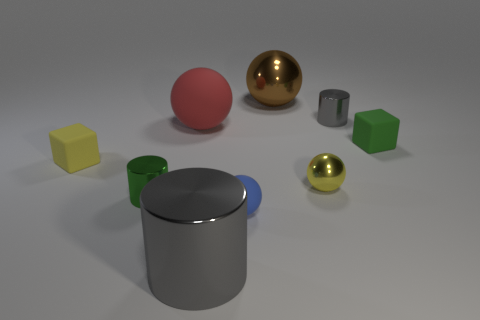Is the size of the gray metal thing on the left side of the big brown shiny ball the same as the shiny cylinder on the right side of the large gray shiny thing?
Your response must be concise. No. There is a large rubber thing that is the same shape as the yellow metal object; what is its color?
Offer a terse response. Red. Does the small green rubber object have the same shape as the red rubber thing?
Keep it short and to the point. No. What is the size of the other rubber object that is the same shape as the tiny green matte object?
Ensure brevity in your answer.  Small. What number of tiny yellow objects are made of the same material as the red sphere?
Keep it short and to the point. 1. What number of objects are either brown objects or balls?
Provide a short and direct response. 4. Is there a large cylinder that is behind the green thing that is right of the tiny blue sphere?
Give a very brief answer. No. Is the number of big gray cylinders to the left of the small rubber ball greater than the number of green matte blocks that are left of the small yellow ball?
Your answer should be compact. Yes. What is the material of the tiny block that is the same color as the small shiny sphere?
Your response must be concise. Rubber. How many tiny metal cylinders are the same color as the big cylinder?
Provide a short and direct response. 1. 